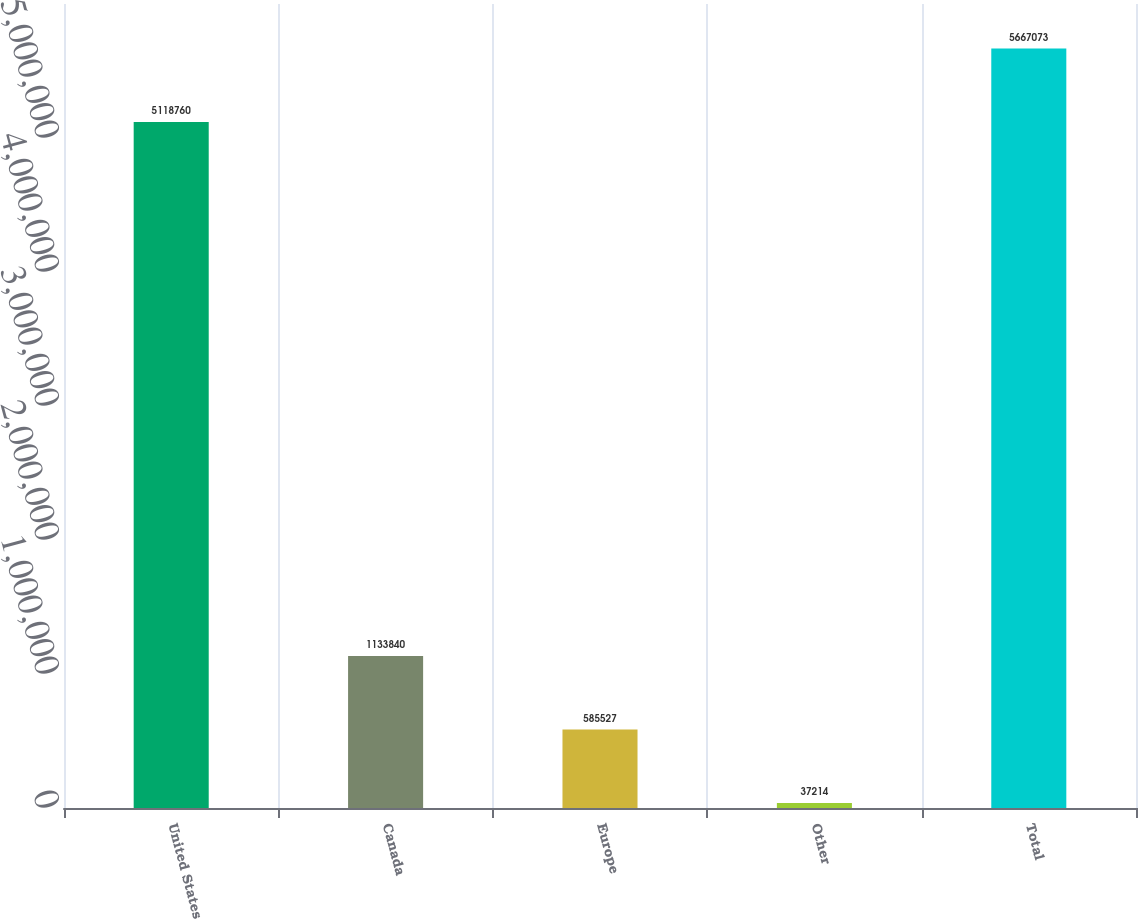<chart> <loc_0><loc_0><loc_500><loc_500><bar_chart><fcel>United States<fcel>Canada<fcel>Europe<fcel>Other<fcel>Total<nl><fcel>5.11876e+06<fcel>1.13384e+06<fcel>585527<fcel>37214<fcel>5.66707e+06<nl></chart> 